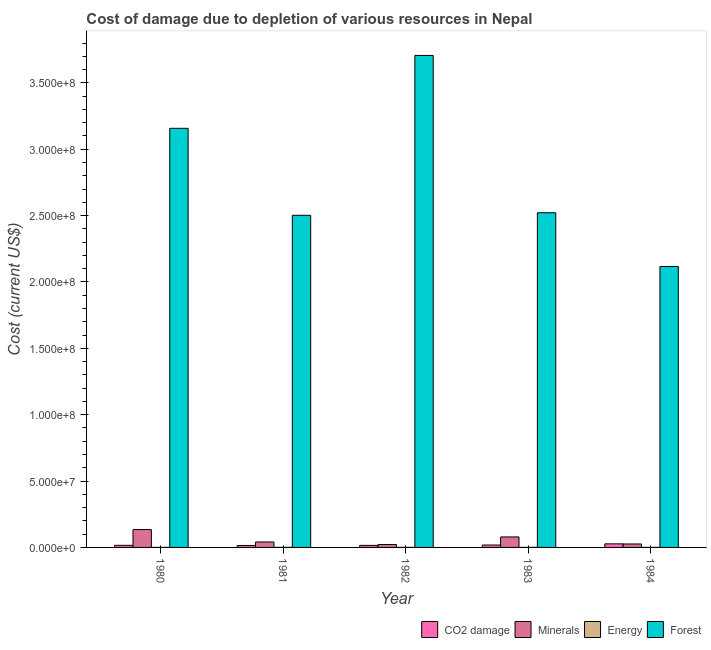How many groups of bars are there?
Make the answer very short. 5. Are the number of bars per tick equal to the number of legend labels?
Provide a succinct answer. Yes. How many bars are there on the 4th tick from the left?
Provide a short and direct response. 4. In how many cases, is the number of bars for a given year not equal to the number of legend labels?
Provide a succinct answer. 0. What is the cost of damage due to depletion of minerals in 1981?
Offer a terse response. 4.10e+06. Across all years, what is the maximum cost of damage due to depletion of coal?
Give a very brief answer. 2.69e+06. Across all years, what is the minimum cost of damage due to depletion of coal?
Provide a succinct answer. 1.47e+06. In which year was the cost of damage due to depletion of coal maximum?
Give a very brief answer. 1984. What is the total cost of damage due to depletion of coal in the graph?
Your response must be concise. 9.10e+06. What is the difference between the cost of damage due to depletion of energy in 1980 and that in 1984?
Your response must be concise. 561.95. What is the difference between the cost of damage due to depletion of minerals in 1982 and the cost of damage due to depletion of forests in 1984?
Provide a succinct answer. -4.16e+05. What is the average cost of damage due to depletion of minerals per year?
Offer a terse response. 6.05e+06. In how many years, is the cost of damage due to depletion of forests greater than 110000000 US$?
Offer a very short reply. 5. What is the ratio of the cost of damage due to depletion of energy in 1980 to that in 1984?
Provide a succinct answer. 1.05. Is the difference between the cost of damage due to depletion of minerals in 1980 and 1984 greater than the difference between the cost of damage due to depletion of coal in 1980 and 1984?
Your answer should be very brief. No. What is the difference between the highest and the second highest cost of damage due to depletion of forests?
Provide a succinct answer. 5.49e+07. What is the difference between the highest and the lowest cost of damage due to depletion of coal?
Your answer should be compact. 1.22e+06. What does the 4th bar from the left in 1983 represents?
Your answer should be compact. Forest. What does the 1st bar from the right in 1981 represents?
Keep it short and to the point. Forest. Is it the case that in every year, the sum of the cost of damage due to depletion of coal and cost of damage due to depletion of minerals is greater than the cost of damage due to depletion of energy?
Give a very brief answer. Yes. How many bars are there?
Offer a very short reply. 20. How many years are there in the graph?
Your response must be concise. 5. Where does the legend appear in the graph?
Provide a short and direct response. Bottom right. What is the title of the graph?
Offer a very short reply. Cost of damage due to depletion of various resources in Nepal . Does "Grants and Revenue" appear as one of the legend labels in the graph?
Provide a succinct answer. No. What is the label or title of the X-axis?
Provide a succinct answer. Year. What is the label or title of the Y-axis?
Keep it short and to the point. Cost (current US$). What is the Cost (current US$) of CO2 damage in 1980?
Your response must be concise. 1.59e+06. What is the Cost (current US$) of Minerals in 1980?
Offer a terse response. 1.35e+07. What is the Cost (current US$) of Energy in 1980?
Give a very brief answer. 1.29e+04. What is the Cost (current US$) of Forest in 1980?
Make the answer very short. 3.16e+08. What is the Cost (current US$) in CO2 damage in 1981?
Your answer should be compact. 1.47e+06. What is the Cost (current US$) in Minerals in 1981?
Offer a terse response. 4.10e+06. What is the Cost (current US$) of Energy in 1981?
Offer a very short reply. 2.94e+04. What is the Cost (current US$) in Forest in 1981?
Keep it short and to the point. 2.50e+08. What is the Cost (current US$) in CO2 damage in 1982?
Give a very brief answer. 1.54e+06. What is the Cost (current US$) in Minerals in 1982?
Offer a very short reply. 2.18e+06. What is the Cost (current US$) of Energy in 1982?
Provide a succinct answer. 3.48e+04. What is the Cost (current US$) in Forest in 1982?
Provide a succinct answer. 3.71e+08. What is the Cost (current US$) in CO2 damage in 1983?
Your answer should be compact. 1.81e+06. What is the Cost (current US$) in Minerals in 1983?
Offer a very short reply. 7.91e+06. What is the Cost (current US$) of Energy in 1983?
Give a very brief answer. 1.91e+04. What is the Cost (current US$) in Forest in 1983?
Your answer should be very brief. 2.52e+08. What is the Cost (current US$) in CO2 damage in 1984?
Your response must be concise. 2.69e+06. What is the Cost (current US$) of Minerals in 1984?
Provide a succinct answer. 2.60e+06. What is the Cost (current US$) in Energy in 1984?
Give a very brief answer. 1.23e+04. What is the Cost (current US$) in Forest in 1984?
Your answer should be compact. 2.12e+08. Across all years, what is the maximum Cost (current US$) of CO2 damage?
Ensure brevity in your answer.  2.69e+06. Across all years, what is the maximum Cost (current US$) of Minerals?
Your answer should be compact. 1.35e+07. Across all years, what is the maximum Cost (current US$) in Energy?
Your answer should be compact. 3.48e+04. Across all years, what is the maximum Cost (current US$) of Forest?
Ensure brevity in your answer.  3.71e+08. Across all years, what is the minimum Cost (current US$) in CO2 damage?
Provide a succinct answer. 1.47e+06. Across all years, what is the minimum Cost (current US$) in Minerals?
Your answer should be compact. 2.18e+06. Across all years, what is the minimum Cost (current US$) of Energy?
Offer a very short reply. 1.23e+04. Across all years, what is the minimum Cost (current US$) in Forest?
Your answer should be very brief. 2.12e+08. What is the total Cost (current US$) in CO2 damage in the graph?
Provide a succinct answer. 9.10e+06. What is the total Cost (current US$) in Minerals in the graph?
Provide a succinct answer. 3.03e+07. What is the total Cost (current US$) of Energy in the graph?
Provide a succinct answer. 1.09e+05. What is the total Cost (current US$) of Forest in the graph?
Offer a terse response. 1.40e+09. What is the difference between the Cost (current US$) in CO2 damage in 1980 and that in 1981?
Provide a succinct answer. 1.16e+05. What is the difference between the Cost (current US$) of Minerals in 1980 and that in 1981?
Your response must be concise. 9.37e+06. What is the difference between the Cost (current US$) in Energy in 1980 and that in 1981?
Make the answer very short. -1.65e+04. What is the difference between the Cost (current US$) in Forest in 1980 and that in 1981?
Ensure brevity in your answer.  6.55e+07. What is the difference between the Cost (current US$) of CO2 damage in 1980 and that in 1982?
Your answer should be compact. 4.47e+04. What is the difference between the Cost (current US$) in Minerals in 1980 and that in 1982?
Provide a short and direct response. 1.13e+07. What is the difference between the Cost (current US$) in Energy in 1980 and that in 1982?
Your response must be concise. -2.19e+04. What is the difference between the Cost (current US$) of Forest in 1980 and that in 1982?
Keep it short and to the point. -5.49e+07. What is the difference between the Cost (current US$) in CO2 damage in 1980 and that in 1983?
Your answer should be compact. -2.22e+05. What is the difference between the Cost (current US$) in Minerals in 1980 and that in 1983?
Provide a succinct answer. 5.56e+06. What is the difference between the Cost (current US$) in Energy in 1980 and that in 1983?
Provide a short and direct response. -6195.2. What is the difference between the Cost (current US$) of Forest in 1980 and that in 1983?
Your answer should be compact. 6.36e+07. What is the difference between the Cost (current US$) of CO2 damage in 1980 and that in 1984?
Offer a terse response. -1.11e+06. What is the difference between the Cost (current US$) in Minerals in 1980 and that in 1984?
Ensure brevity in your answer.  1.09e+07. What is the difference between the Cost (current US$) of Energy in 1980 and that in 1984?
Give a very brief answer. 561.95. What is the difference between the Cost (current US$) of Forest in 1980 and that in 1984?
Offer a very short reply. 1.04e+08. What is the difference between the Cost (current US$) in CO2 damage in 1981 and that in 1982?
Make the answer very short. -7.13e+04. What is the difference between the Cost (current US$) of Minerals in 1981 and that in 1982?
Your answer should be compact. 1.92e+06. What is the difference between the Cost (current US$) in Energy in 1981 and that in 1982?
Provide a short and direct response. -5470.79. What is the difference between the Cost (current US$) in Forest in 1981 and that in 1982?
Offer a very short reply. -1.20e+08. What is the difference between the Cost (current US$) of CO2 damage in 1981 and that in 1983?
Your answer should be compact. -3.39e+05. What is the difference between the Cost (current US$) in Minerals in 1981 and that in 1983?
Make the answer very short. -3.80e+06. What is the difference between the Cost (current US$) of Energy in 1981 and that in 1983?
Make the answer very short. 1.03e+04. What is the difference between the Cost (current US$) in Forest in 1981 and that in 1983?
Your response must be concise. -1.92e+06. What is the difference between the Cost (current US$) in CO2 damage in 1981 and that in 1984?
Offer a terse response. -1.22e+06. What is the difference between the Cost (current US$) of Minerals in 1981 and that in 1984?
Provide a short and direct response. 1.50e+06. What is the difference between the Cost (current US$) of Energy in 1981 and that in 1984?
Offer a terse response. 1.70e+04. What is the difference between the Cost (current US$) of Forest in 1981 and that in 1984?
Offer a terse response. 3.86e+07. What is the difference between the Cost (current US$) of CO2 damage in 1982 and that in 1983?
Give a very brief answer. -2.67e+05. What is the difference between the Cost (current US$) of Minerals in 1982 and that in 1983?
Your answer should be compact. -5.72e+06. What is the difference between the Cost (current US$) in Energy in 1982 and that in 1983?
Provide a short and direct response. 1.57e+04. What is the difference between the Cost (current US$) in Forest in 1982 and that in 1983?
Ensure brevity in your answer.  1.19e+08. What is the difference between the Cost (current US$) in CO2 damage in 1982 and that in 1984?
Your response must be concise. -1.15e+06. What is the difference between the Cost (current US$) in Minerals in 1982 and that in 1984?
Make the answer very short. -4.16e+05. What is the difference between the Cost (current US$) in Energy in 1982 and that in 1984?
Give a very brief answer. 2.25e+04. What is the difference between the Cost (current US$) of Forest in 1982 and that in 1984?
Give a very brief answer. 1.59e+08. What is the difference between the Cost (current US$) in CO2 damage in 1983 and that in 1984?
Make the answer very short. -8.86e+05. What is the difference between the Cost (current US$) of Minerals in 1983 and that in 1984?
Keep it short and to the point. 5.31e+06. What is the difference between the Cost (current US$) of Energy in 1983 and that in 1984?
Your answer should be compact. 6757.15. What is the difference between the Cost (current US$) of Forest in 1983 and that in 1984?
Give a very brief answer. 4.05e+07. What is the difference between the Cost (current US$) in CO2 damage in 1980 and the Cost (current US$) in Minerals in 1981?
Provide a short and direct response. -2.52e+06. What is the difference between the Cost (current US$) of CO2 damage in 1980 and the Cost (current US$) of Energy in 1981?
Provide a short and direct response. 1.56e+06. What is the difference between the Cost (current US$) in CO2 damage in 1980 and the Cost (current US$) in Forest in 1981?
Provide a short and direct response. -2.49e+08. What is the difference between the Cost (current US$) of Minerals in 1980 and the Cost (current US$) of Energy in 1981?
Offer a very short reply. 1.34e+07. What is the difference between the Cost (current US$) of Minerals in 1980 and the Cost (current US$) of Forest in 1981?
Make the answer very short. -2.37e+08. What is the difference between the Cost (current US$) of Energy in 1980 and the Cost (current US$) of Forest in 1981?
Ensure brevity in your answer.  -2.50e+08. What is the difference between the Cost (current US$) of CO2 damage in 1980 and the Cost (current US$) of Minerals in 1982?
Your response must be concise. -5.97e+05. What is the difference between the Cost (current US$) of CO2 damage in 1980 and the Cost (current US$) of Energy in 1982?
Your response must be concise. 1.55e+06. What is the difference between the Cost (current US$) of CO2 damage in 1980 and the Cost (current US$) of Forest in 1982?
Give a very brief answer. -3.69e+08. What is the difference between the Cost (current US$) of Minerals in 1980 and the Cost (current US$) of Energy in 1982?
Your response must be concise. 1.34e+07. What is the difference between the Cost (current US$) in Minerals in 1980 and the Cost (current US$) in Forest in 1982?
Provide a short and direct response. -3.57e+08. What is the difference between the Cost (current US$) in Energy in 1980 and the Cost (current US$) in Forest in 1982?
Provide a short and direct response. -3.71e+08. What is the difference between the Cost (current US$) in CO2 damage in 1980 and the Cost (current US$) in Minerals in 1983?
Your response must be concise. -6.32e+06. What is the difference between the Cost (current US$) in CO2 damage in 1980 and the Cost (current US$) in Energy in 1983?
Your response must be concise. 1.57e+06. What is the difference between the Cost (current US$) in CO2 damage in 1980 and the Cost (current US$) in Forest in 1983?
Provide a succinct answer. -2.51e+08. What is the difference between the Cost (current US$) of Minerals in 1980 and the Cost (current US$) of Energy in 1983?
Keep it short and to the point. 1.34e+07. What is the difference between the Cost (current US$) of Minerals in 1980 and the Cost (current US$) of Forest in 1983?
Offer a very short reply. -2.39e+08. What is the difference between the Cost (current US$) in Energy in 1980 and the Cost (current US$) in Forest in 1983?
Provide a short and direct response. -2.52e+08. What is the difference between the Cost (current US$) in CO2 damage in 1980 and the Cost (current US$) in Minerals in 1984?
Your answer should be compact. -1.01e+06. What is the difference between the Cost (current US$) of CO2 damage in 1980 and the Cost (current US$) of Energy in 1984?
Your answer should be very brief. 1.57e+06. What is the difference between the Cost (current US$) in CO2 damage in 1980 and the Cost (current US$) in Forest in 1984?
Make the answer very short. -2.10e+08. What is the difference between the Cost (current US$) in Minerals in 1980 and the Cost (current US$) in Energy in 1984?
Ensure brevity in your answer.  1.35e+07. What is the difference between the Cost (current US$) of Minerals in 1980 and the Cost (current US$) of Forest in 1984?
Make the answer very short. -1.98e+08. What is the difference between the Cost (current US$) of Energy in 1980 and the Cost (current US$) of Forest in 1984?
Keep it short and to the point. -2.12e+08. What is the difference between the Cost (current US$) in CO2 damage in 1981 and the Cost (current US$) in Minerals in 1982?
Give a very brief answer. -7.13e+05. What is the difference between the Cost (current US$) in CO2 damage in 1981 and the Cost (current US$) in Energy in 1982?
Your answer should be very brief. 1.43e+06. What is the difference between the Cost (current US$) of CO2 damage in 1981 and the Cost (current US$) of Forest in 1982?
Ensure brevity in your answer.  -3.69e+08. What is the difference between the Cost (current US$) in Minerals in 1981 and the Cost (current US$) in Energy in 1982?
Provide a succinct answer. 4.07e+06. What is the difference between the Cost (current US$) of Minerals in 1981 and the Cost (current US$) of Forest in 1982?
Offer a terse response. -3.67e+08. What is the difference between the Cost (current US$) of Energy in 1981 and the Cost (current US$) of Forest in 1982?
Your response must be concise. -3.71e+08. What is the difference between the Cost (current US$) of CO2 damage in 1981 and the Cost (current US$) of Minerals in 1983?
Make the answer very short. -6.44e+06. What is the difference between the Cost (current US$) in CO2 damage in 1981 and the Cost (current US$) in Energy in 1983?
Provide a succinct answer. 1.45e+06. What is the difference between the Cost (current US$) of CO2 damage in 1981 and the Cost (current US$) of Forest in 1983?
Ensure brevity in your answer.  -2.51e+08. What is the difference between the Cost (current US$) in Minerals in 1981 and the Cost (current US$) in Energy in 1983?
Your answer should be compact. 4.08e+06. What is the difference between the Cost (current US$) of Minerals in 1981 and the Cost (current US$) of Forest in 1983?
Your answer should be compact. -2.48e+08. What is the difference between the Cost (current US$) of Energy in 1981 and the Cost (current US$) of Forest in 1983?
Give a very brief answer. -2.52e+08. What is the difference between the Cost (current US$) of CO2 damage in 1981 and the Cost (current US$) of Minerals in 1984?
Give a very brief answer. -1.13e+06. What is the difference between the Cost (current US$) in CO2 damage in 1981 and the Cost (current US$) in Energy in 1984?
Your response must be concise. 1.46e+06. What is the difference between the Cost (current US$) of CO2 damage in 1981 and the Cost (current US$) of Forest in 1984?
Keep it short and to the point. -2.10e+08. What is the difference between the Cost (current US$) of Minerals in 1981 and the Cost (current US$) of Energy in 1984?
Provide a succinct answer. 4.09e+06. What is the difference between the Cost (current US$) of Minerals in 1981 and the Cost (current US$) of Forest in 1984?
Ensure brevity in your answer.  -2.08e+08. What is the difference between the Cost (current US$) of Energy in 1981 and the Cost (current US$) of Forest in 1984?
Provide a short and direct response. -2.12e+08. What is the difference between the Cost (current US$) of CO2 damage in 1982 and the Cost (current US$) of Minerals in 1983?
Provide a short and direct response. -6.36e+06. What is the difference between the Cost (current US$) in CO2 damage in 1982 and the Cost (current US$) in Energy in 1983?
Your response must be concise. 1.52e+06. What is the difference between the Cost (current US$) of CO2 damage in 1982 and the Cost (current US$) of Forest in 1983?
Ensure brevity in your answer.  -2.51e+08. What is the difference between the Cost (current US$) in Minerals in 1982 and the Cost (current US$) in Energy in 1983?
Offer a terse response. 2.16e+06. What is the difference between the Cost (current US$) of Minerals in 1982 and the Cost (current US$) of Forest in 1983?
Provide a short and direct response. -2.50e+08. What is the difference between the Cost (current US$) of Energy in 1982 and the Cost (current US$) of Forest in 1983?
Offer a very short reply. -2.52e+08. What is the difference between the Cost (current US$) in CO2 damage in 1982 and the Cost (current US$) in Minerals in 1984?
Your answer should be compact. -1.06e+06. What is the difference between the Cost (current US$) in CO2 damage in 1982 and the Cost (current US$) in Energy in 1984?
Your answer should be compact. 1.53e+06. What is the difference between the Cost (current US$) of CO2 damage in 1982 and the Cost (current US$) of Forest in 1984?
Your response must be concise. -2.10e+08. What is the difference between the Cost (current US$) in Minerals in 1982 and the Cost (current US$) in Energy in 1984?
Provide a short and direct response. 2.17e+06. What is the difference between the Cost (current US$) in Minerals in 1982 and the Cost (current US$) in Forest in 1984?
Provide a short and direct response. -2.09e+08. What is the difference between the Cost (current US$) in Energy in 1982 and the Cost (current US$) in Forest in 1984?
Provide a succinct answer. -2.12e+08. What is the difference between the Cost (current US$) of CO2 damage in 1983 and the Cost (current US$) of Minerals in 1984?
Offer a terse response. -7.90e+05. What is the difference between the Cost (current US$) of CO2 damage in 1983 and the Cost (current US$) of Energy in 1984?
Your answer should be very brief. 1.80e+06. What is the difference between the Cost (current US$) of CO2 damage in 1983 and the Cost (current US$) of Forest in 1984?
Give a very brief answer. -2.10e+08. What is the difference between the Cost (current US$) in Minerals in 1983 and the Cost (current US$) in Energy in 1984?
Provide a succinct answer. 7.89e+06. What is the difference between the Cost (current US$) of Minerals in 1983 and the Cost (current US$) of Forest in 1984?
Offer a terse response. -2.04e+08. What is the difference between the Cost (current US$) of Energy in 1983 and the Cost (current US$) of Forest in 1984?
Offer a terse response. -2.12e+08. What is the average Cost (current US$) in CO2 damage per year?
Offer a very short reply. 1.82e+06. What is the average Cost (current US$) of Minerals per year?
Keep it short and to the point. 6.05e+06. What is the average Cost (current US$) of Energy per year?
Your answer should be very brief. 2.17e+04. What is the average Cost (current US$) of Forest per year?
Your response must be concise. 2.80e+08. In the year 1980, what is the difference between the Cost (current US$) of CO2 damage and Cost (current US$) of Minerals?
Provide a short and direct response. -1.19e+07. In the year 1980, what is the difference between the Cost (current US$) in CO2 damage and Cost (current US$) in Energy?
Give a very brief answer. 1.57e+06. In the year 1980, what is the difference between the Cost (current US$) of CO2 damage and Cost (current US$) of Forest?
Make the answer very short. -3.14e+08. In the year 1980, what is the difference between the Cost (current US$) in Minerals and Cost (current US$) in Energy?
Provide a short and direct response. 1.35e+07. In the year 1980, what is the difference between the Cost (current US$) of Minerals and Cost (current US$) of Forest?
Provide a succinct answer. -3.02e+08. In the year 1980, what is the difference between the Cost (current US$) in Energy and Cost (current US$) in Forest?
Offer a terse response. -3.16e+08. In the year 1981, what is the difference between the Cost (current US$) in CO2 damage and Cost (current US$) in Minerals?
Give a very brief answer. -2.63e+06. In the year 1981, what is the difference between the Cost (current US$) in CO2 damage and Cost (current US$) in Energy?
Ensure brevity in your answer.  1.44e+06. In the year 1981, what is the difference between the Cost (current US$) of CO2 damage and Cost (current US$) of Forest?
Your response must be concise. -2.49e+08. In the year 1981, what is the difference between the Cost (current US$) of Minerals and Cost (current US$) of Energy?
Make the answer very short. 4.07e+06. In the year 1981, what is the difference between the Cost (current US$) of Minerals and Cost (current US$) of Forest?
Your answer should be very brief. -2.46e+08. In the year 1981, what is the difference between the Cost (current US$) of Energy and Cost (current US$) of Forest?
Your answer should be compact. -2.50e+08. In the year 1982, what is the difference between the Cost (current US$) in CO2 damage and Cost (current US$) in Minerals?
Your answer should be compact. -6.41e+05. In the year 1982, what is the difference between the Cost (current US$) of CO2 damage and Cost (current US$) of Energy?
Keep it short and to the point. 1.51e+06. In the year 1982, what is the difference between the Cost (current US$) of CO2 damage and Cost (current US$) of Forest?
Provide a short and direct response. -3.69e+08. In the year 1982, what is the difference between the Cost (current US$) in Minerals and Cost (current US$) in Energy?
Make the answer very short. 2.15e+06. In the year 1982, what is the difference between the Cost (current US$) of Minerals and Cost (current US$) of Forest?
Your answer should be compact. -3.68e+08. In the year 1982, what is the difference between the Cost (current US$) of Energy and Cost (current US$) of Forest?
Your answer should be very brief. -3.71e+08. In the year 1983, what is the difference between the Cost (current US$) of CO2 damage and Cost (current US$) of Minerals?
Your answer should be compact. -6.10e+06. In the year 1983, what is the difference between the Cost (current US$) in CO2 damage and Cost (current US$) in Energy?
Your answer should be compact. 1.79e+06. In the year 1983, what is the difference between the Cost (current US$) of CO2 damage and Cost (current US$) of Forest?
Your response must be concise. -2.50e+08. In the year 1983, what is the difference between the Cost (current US$) of Minerals and Cost (current US$) of Energy?
Offer a very short reply. 7.89e+06. In the year 1983, what is the difference between the Cost (current US$) in Minerals and Cost (current US$) in Forest?
Give a very brief answer. -2.44e+08. In the year 1983, what is the difference between the Cost (current US$) of Energy and Cost (current US$) of Forest?
Ensure brevity in your answer.  -2.52e+08. In the year 1984, what is the difference between the Cost (current US$) of CO2 damage and Cost (current US$) of Minerals?
Your answer should be compact. 9.57e+04. In the year 1984, what is the difference between the Cost (current US$) of CO2 damage and Cost (current US$) of Energy?
Offer a terse response. 2.68e+06. In the year 1984, what is the difference between the Cost (current US$) in CO2 damage and Cost (current US$) in Forest?
Make the answer very short. -2.09e+08. In the year 1984, what is the difference between the Cost (current US$) in Minerals and Cost (current US$) in Energy?
Provide a short and direct response. 2.59e+06. In the year 1984, what is the difference between the Cost (current US$) of Minerals and Cost (current US$) of Forest?
Offer a terse response. -2.09e+08. In the year 1984, what is the difference between the Cost (current US$) of Energy and Cost (current US$) of Forest?
Offer a terse response. -2.12e+08. What is the ratio of the Cost (current US$) in CO2 damage in 1980 to that in 1981?
Your answer should be compact. 1.08. What is the ratio of the Cost (current US$) in Minerals in 1980 to that in 1981?
Your response must be concise. 3.28. What is the ratio of the Cost (current US$) of Energy in 1980 to that in 1981?
Offer a very short reply. 0.44. What is the ratio of the Cost (current US$) in Forest in 1980 to that in 1981?
Offer a very short reply. 1.26. What is the ratio of the Cost (current US$) in Minerals in 1980 to that in 1982?
Provide a short and direct response. 6.17. What is the ratio of the Cost (current US$) in Energy in 1980 to that in 1982?
Make the answer very short. 0.37. What is the ratio of the Cost (current US$) in Forest in 1980 to that in 1982?
Keep it short and to the point. 0.85. What is the ratio of the Cost (current US$) in CO2 damage in 1980 to that in 1983?
Your response must be concise. 0.88. What is the ratio of the Cost (current US$) of Minerals in 1980 to that in 1983?
Provide a succinct answer. 1.7. What is the ratio of the Cost (current US$) in Energy in 1980 to that in 1983?
Make the answer very short. 0.68. What is the ratio of the Cost (current US$) of Forest in 1980 to that in 1983?
Make the answer very short. 1.25. What is the ratio of the Cost (current US$) of CO2 damage in 1980 to that in 1984?
Ensure brevity in your answer.  0.59. What is the ratio of the Cost (current US$) in Minerals in 1980 to that in 1984?
Offer a very short reply. 5.18. What is the ratio of the Cost (current US$) of Energy in 1980 to that in 1984?
Make the answer very short. 1.05. What is the ratio of the Cost (current US$) in Forest in 1980 to that in 1984?
Give a very brief answer. 1.49. What is the ratio of the Cost (current US$) in CO2 damage in 1981 to that in 1982?
Your answer should be compact. 0.95. What is the ratio of the Cost (current US$) of Minerals in 1981 to that in 1982?
Your answer should be compact. 1.88. What is the ratio of the Cost (current US$) of Energy in 1981 to that in 1982?
Give a very brief answer. 0.84. What is the ratio of the Cost (current US$) of Forest in 1981 to that in 1982?
Provide a short and direct response. 0.68. What is the ratio of the Cost (current US$) of CO2 damage in 1981 to that in 1983?
Keep it short and to the point. 0.81. What is the ratio of the Cost (current US$) of Minerals in 1981 to that in 1983?
Your response must be concise. 0.52. What is the ratio of the Cost (current US$) in Energy in 1981 to that in 1983?
Your answer should be compact. 1.54. What is the ratio of the Cost (current US$) of Forest in 1981 to that in 1983?
Offer a terse response. 0.99. What is the ratio of the Cost (current US$) in CO2 damage in 1981 to that in 1984?
Your answer should be very brief. 0.55. What is the ratio of the Cost (current US$) in Minerals in 1981 to that in 1984?
Give a very brief answer. 1.58. What is the ratio of the Cost (current US$) of Energy in 1981 to that in 1984?
Keep it short and to the point. 2.38. What is the ratio of the Cost (current US$) in Forest in 1981 to that in 1984?
Your answer should be very brief. 1.18. What is the ratio of the Cost (current US$) of CO2 damage in 1982 to that in 1983?
Provide a short and direct response. 0.85. What is the ratio of the Cost (current US$) of Minerals in 1982 to that in 1983?
Offer a terse response. 0.28. What is the ratio of the Cost (current US$) in Energy in 1982 to that in 1983?
Make the answer very short. 1.82. What is the ratio of the Cost (current US$) in Forest in 1982 to that in 1983?
Your answer should be very brief. 1.47. What is the ratio of the Cost (current US$) of CO2 damage in 1982 to that in 1984?
Make the answer very short. 0.57. What is the ratio of the Cost (current US$) of Minerals in 1982 to that in 1984?
Keep it short and to the point. 0.84. What is the ratio of the Cost (current US$) of Energy in 1982 to that in 1984?
Keep it short and to the point. 2.82. What is the ratio of the Cost (current US$) of Forest in 1982 to that in 1984?
Offer a terse response. 1.75. What is the ratio of the Cost (current US$) in CO2 damage in 1983 to that in 1984?
Your answer should be compact. 0.67. What is the ratio of the Cost (current US$) of Minerals in 1983 to that in 1984?
Your answer should be very brief. 3.04. What is the ratio of the Cost (current US$) in Energy in 1983 to that in 1984?
Provide a succinct answer. 1.55. What is the ratio of the Cost (current US$) in Forest in 1983 to that in 1984?
Make the answer very short. 1.19. What is the difference between the highest and the second highest Cost (current US$) in CO2 damage?
Your response must be concise. 8.86e+05. What is the difference between the highest and the second highest Cost (current US$) of Minerals?
Your answer should be very brief. 5.56e+06. What is the difference between the highest and the second highest Cost (current US$) in Energy?
Your answer should be compact. 5470.79. What is the difference between the highest and the second highest Cost (current US$) in Forest?
Make the answer very short. 5.49e+07. What is the difference between the highest and the lowest Cost (current US$) in CO2 damage?
Ensure brevity in your answer.  1.22e+06. What is the difference between the highest and the lowest Cost (current US$) of Minerals?
Make the answer very short. 1.13e+07. What is the difference between the highest and the lowest Cost (current US$) of Energy?
Your response must be concise. 2.25e+04. What is the difference between the highest and the lowest Cost (current US$) of Forest?
Your answer should be very brief. 1.59e+08. 